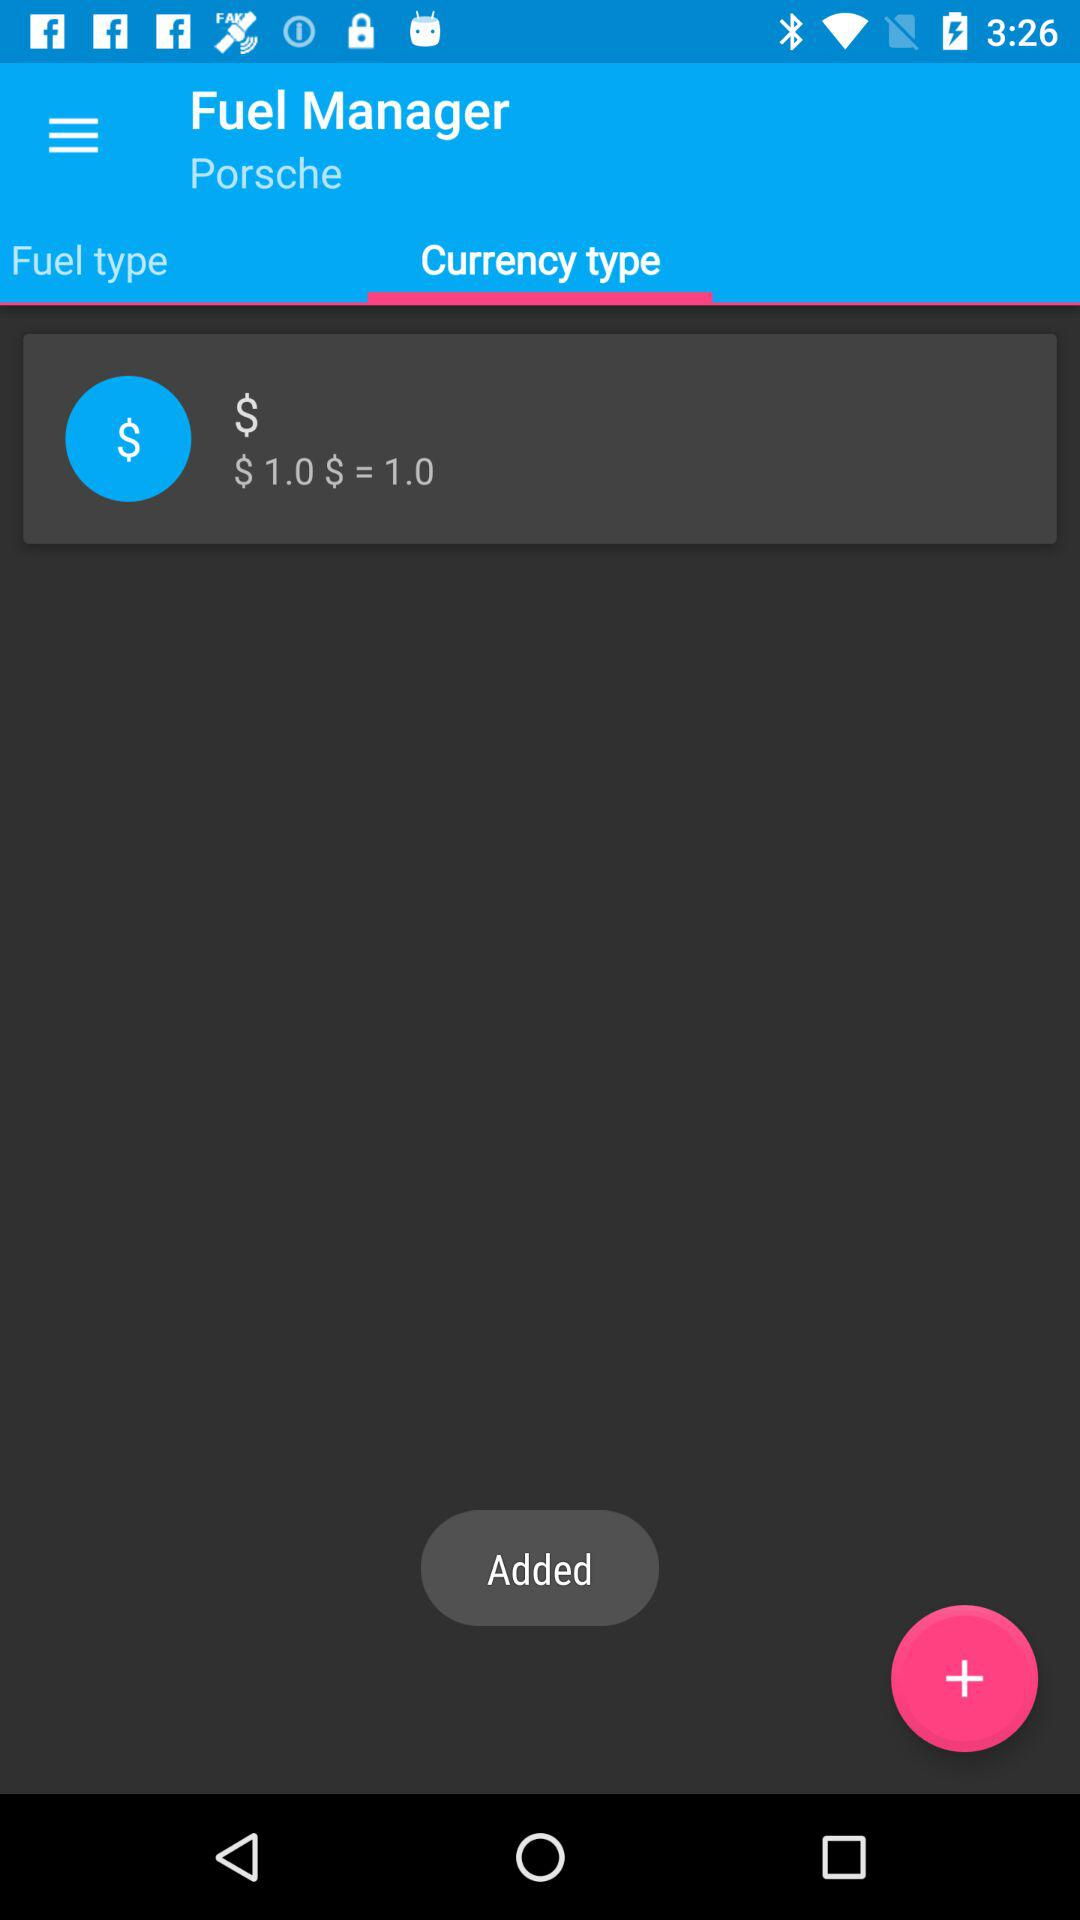What is the application name? The application name is "Fuel Manager". 